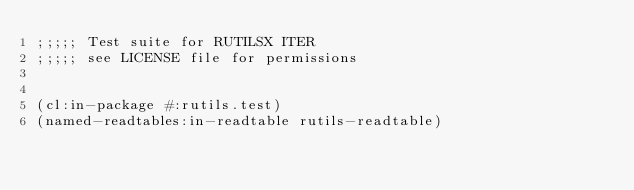Convert code to text. <code><loc_0><loc_0><loc_500><loc_500><_Lisp_>;;;;; Test suite for RUTILSX ITER
;;;;; see LICENSE file for permissions


(cl:in-package #:rutils.test)
(named-readtables:in-readtable rutils-readtable)

</code> 